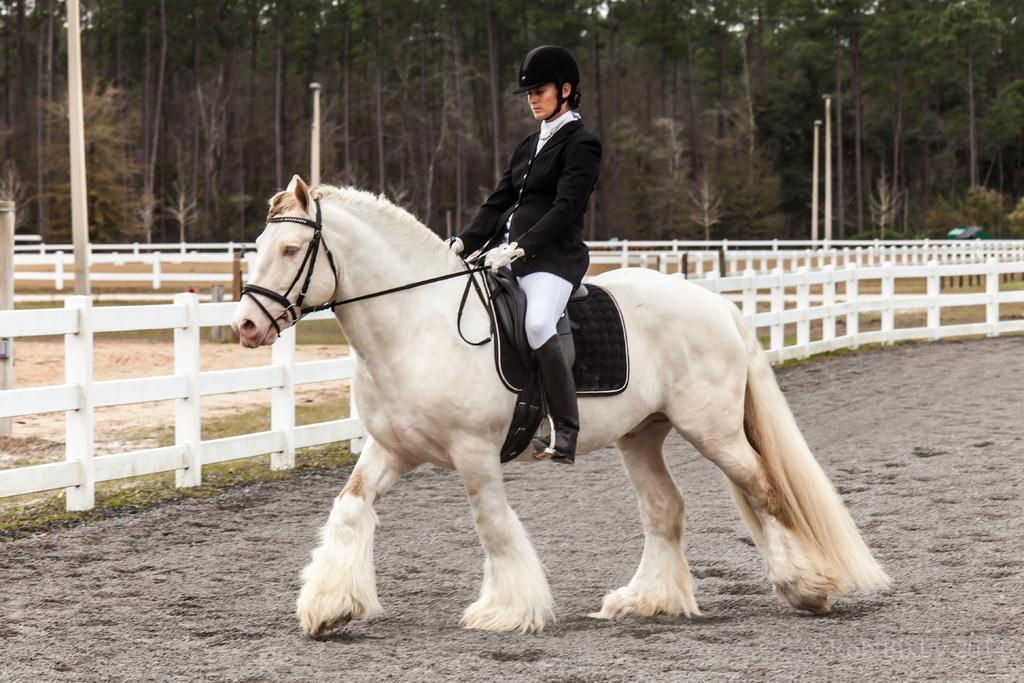Who is the main subject in the image? There is a person in the image. What is the person doing in the image? The person is sitting on a horse. What can be seen in the background of the image? There are many trees in the background of the image. What is the governor's dad doing in the image? There is no mention of a governor or the person's dad in the image, so we cannot answer this question. 